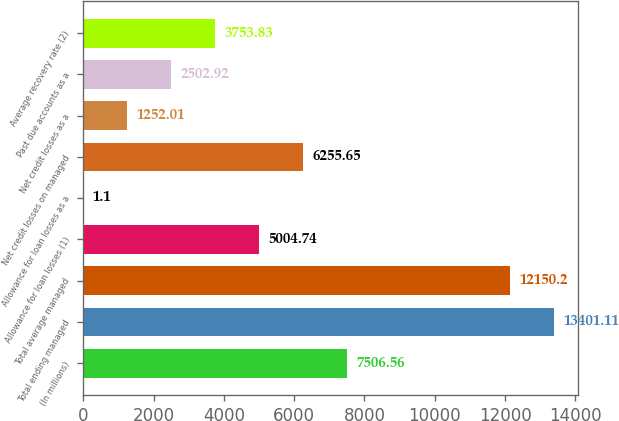Convert chart. <chart><loc_0><loc_0><loc_500><loc_500><bar_chart><fcel>(In millions)<fcel>Total ending managed<fcel>Total average managed<fcel>Allowance for loan losses (1)<fcel>Allowance for loan losses as a<fcel>Net credit losses on managed<fcel>Net credit losses as a<fcel>Past due accounts as a<fcel>Average recovery rate (2)<nl><fcel>7506.56<fcel>13401.1<fcel>12150.2<fcel>5004.74<fcel>1.1<fcel>6255.65<fcel>1252.01<fcel>2502.92<fcel>3753.83<nl></chart> 